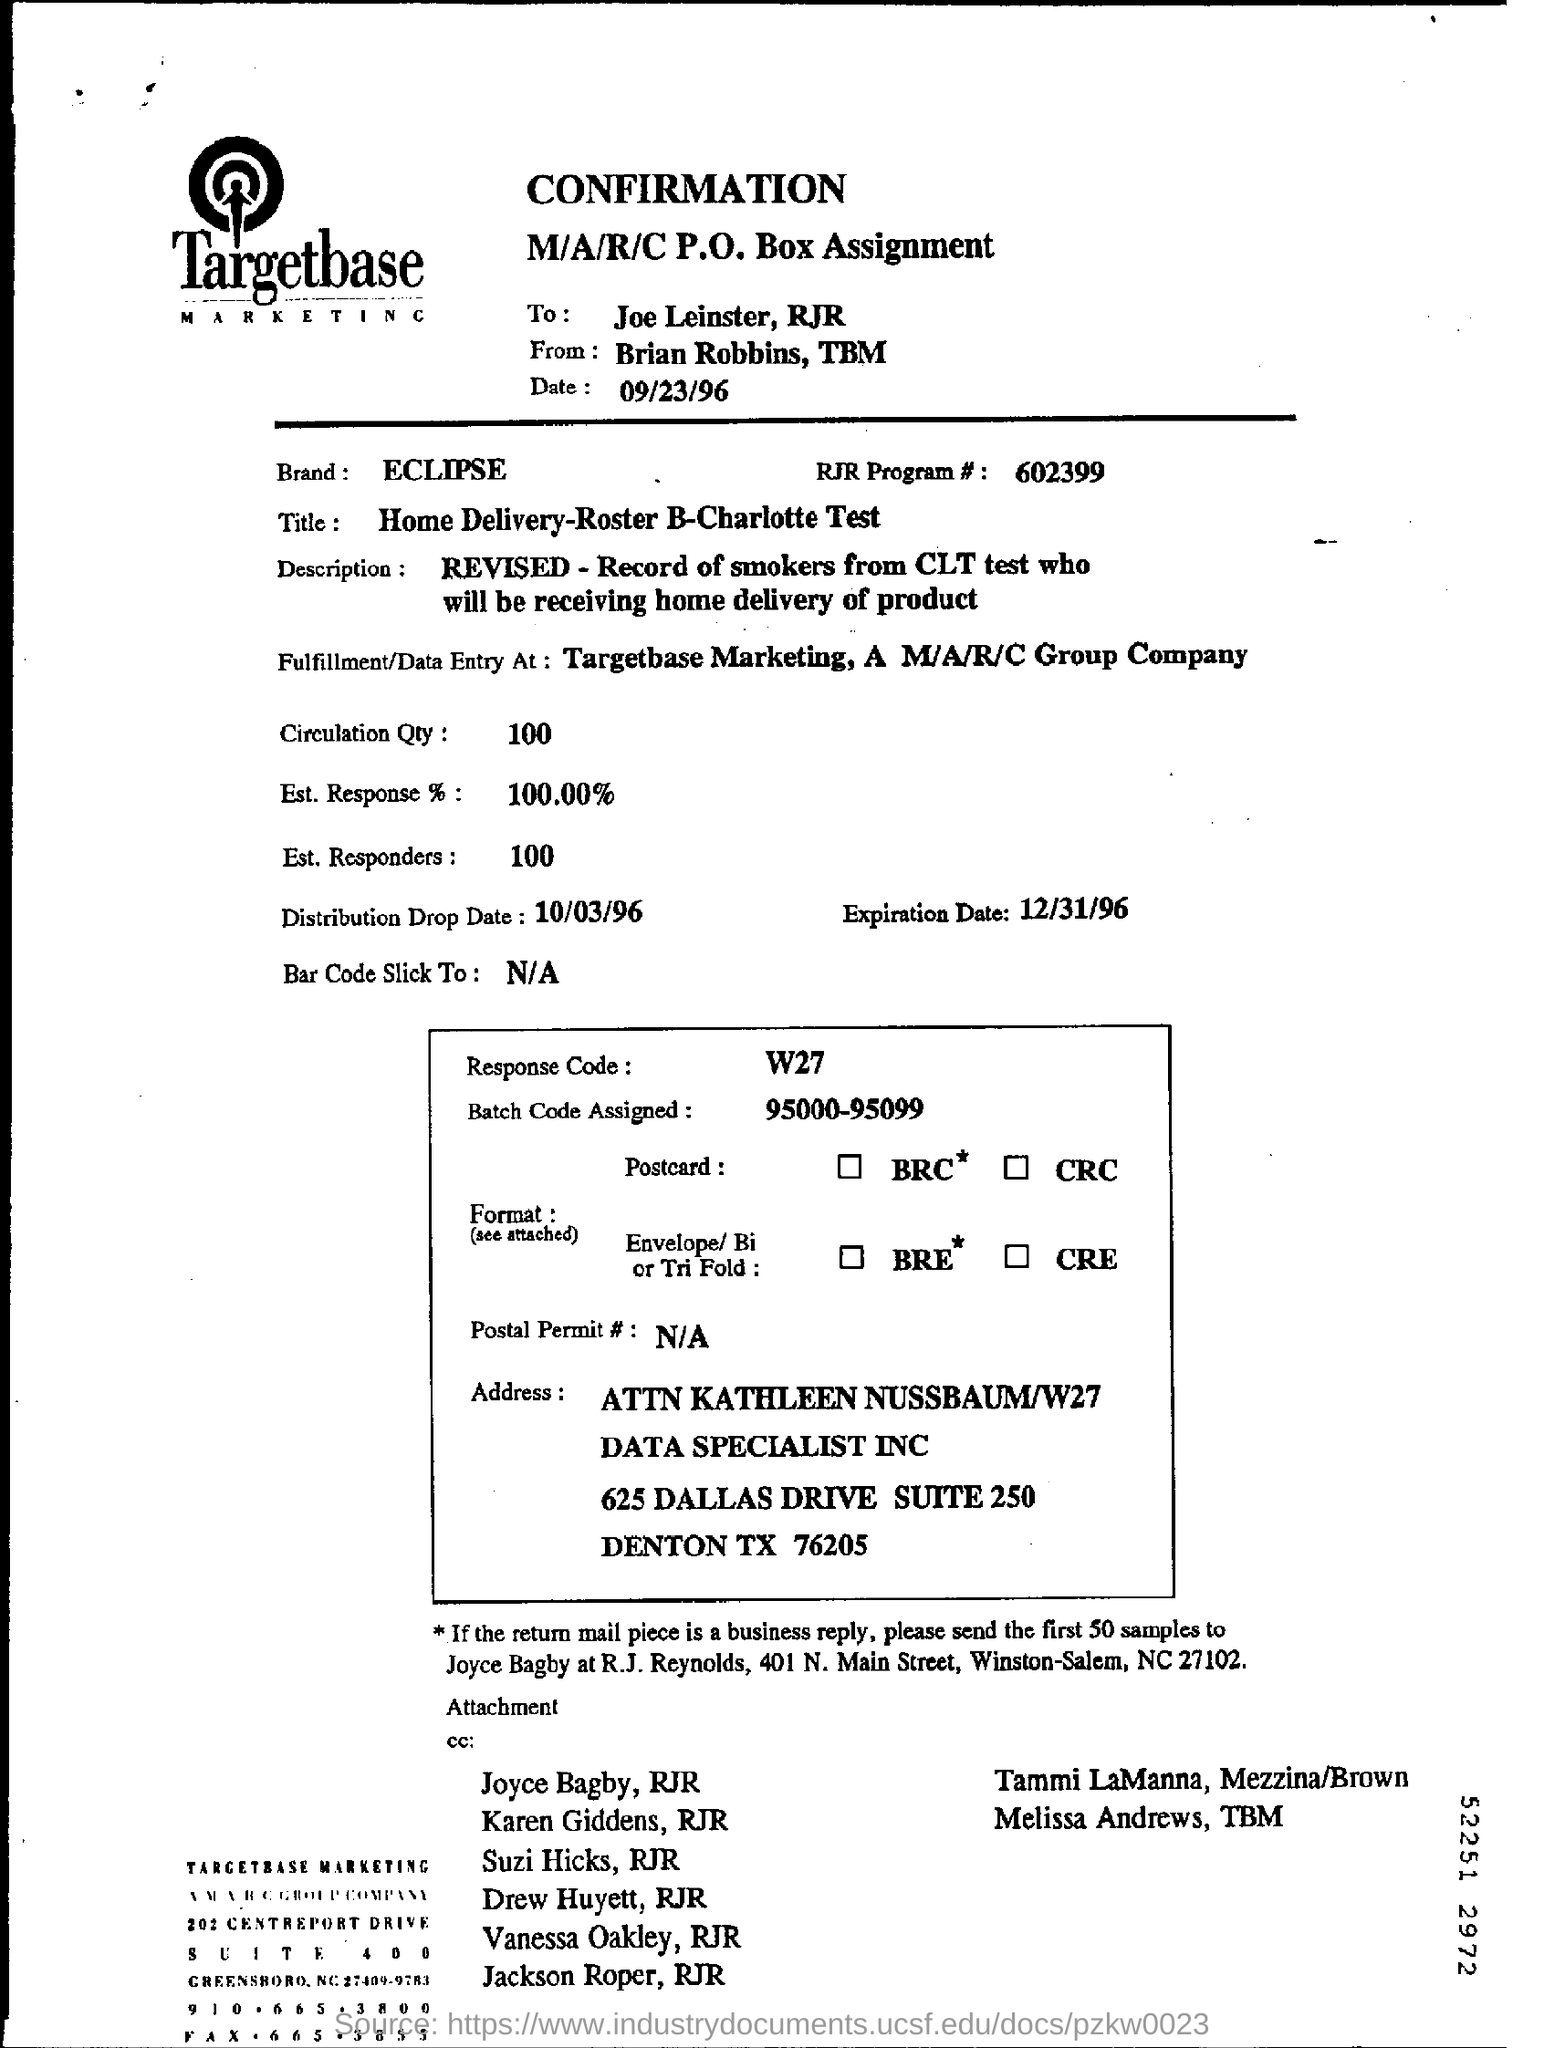What is the name of the brand mentioned?
Offer a terse response. ECLIPSE. What is the title mentioned?
Make the answer very short. Home Delivery-Roster B-Charlotte Test. What is the RJR Program # number?
Ensure brevity in your answer.  602399. What is the Circulation Qty mentioned?
Provide a short and direct response. 100. 